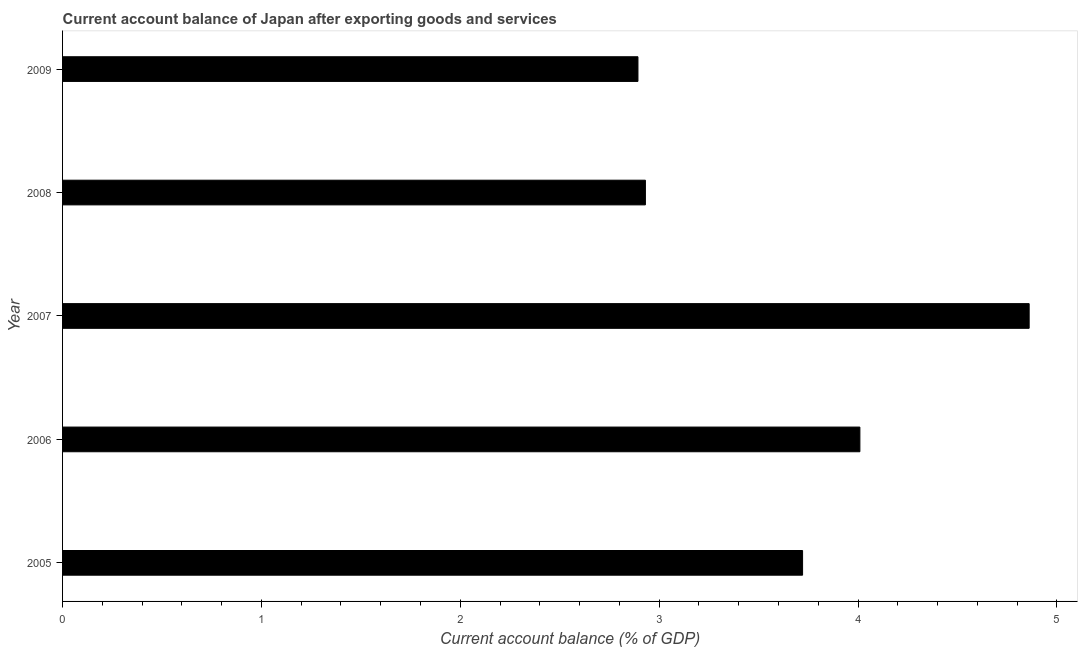Does the graph contain any zero values?
Your answer should be compact. No. What is the title of the graph?
Ensure brevity in your answer.  Current account balance of Japan after exporting goods and services. What is the label or title of the X-axis?
Your answer should be very brief. Current account balance (% of GDP). What is the current account balance in 2009?
Offer a terse response. 2.89. Across all years, what is the maximum current account balance?
Your answer should be compact. 4.86. Across all years, what is the minimum current account balance?
Make the answer very short. 2.89. In which year was the current account balance minimum?
Your response must be concise. 2009. What is the sum of the current account balance?
Give a very brief answer. 18.41. What is the difference between the current account balance in 2006 and 2008?
Offer a terse response. 1.08. What is the average current account balance per year?
Provide a short and direct response. 3.68. What is the median current account balance?
Your response must be concise. 3.72. Do a majority of the years between 2008 and 2007 (inclusive) have current account balance greater than 2.2 %?
Provide a succinct answer. No. What is the ratio of the current account balance in 2006 to that in 2009?
Your answer should be compact. 1.39. Is the current account balance in 2005 less than that in 2006?
Provide a short and direct response. Yes. Is the difference between the current account balance in 2005 and 2006 greater than the difference between any two years?
Your answer should be very brief. No. What is the difference between the highest and the second highest current account balance?
Provide a succinct answer. 0.85. Is the sum of the current account balance in 2007 and 2008 greater than the maximum current account balance across all years?
Keep it short and to the point. Yes. What is the difference between the highest and the lowest current account balance?
Provide a short and direct response. 1.97. In how many years, is the current account balance greater than the average current account balance taken over all years?
Your response must be concise. 3. How many bars are there?
Your answer should be compact. 5. What is the difference between two consecutive major ticks on the X-axis?
Provide a succinct answer. 1. What is the Current account balance (% of GDP) of 2005?
Provide a succinct answer. 3.72. What is the Current account balance (% of GDP) of 2006?
Provide a succinct answer. 4.01. What is the Current account balance (% of GDP) of 2007?
Your answer should be very brief. 4.86. What is the Current account balance (% of GDP) in 2008?
Your answer should be compact. 2.93. What is the Current account balance (% of GDP) of 2009?
Offer a very short reply. 2.89. What is the difference between the Current account balance (% of GDP) in 2005 and 2006?
Provide a short and direct response. -0.29. What is the difference between the Current account balance (% of GDP) in 2005 and 2007?
Your response must be concise. -1.14. What is the difference between the Current account balance (% of GDP) in 2005 and 2008?
Ensure brevity in your answer.  0.79. What is the difference between the Current account balance (% of GDP) in 2005 and 2009?
Provide a succinct answer. 0.83. What is the difference between the Current account balance (% of GDP) in 2006 and 2007?
Your response must be concise. -0.85. What is the difference between the Current account balance (% of GDP) in 2006 and 2008?
Keep it short and to the point. 1.08. What is the difference between the Current account balance (% of GDP) in 2006 and 2009?
Make the answer very short. 1.12. What is the difference between the Current account balance (% of GDP) in 2007 and 2008?
Your answer should be very brief. 1.93. What is the difference between the Current account balance (% of GDP) in 2007 and 2009?
Your response must be concise. 1.97. What is the difference between the Current account balance (% of GDP) in 2008 and 2009?
Provide a short and direct response. 0.04. What is the ratio of the Current account balance (% of GDP) in 2005 to that in 2006?
Your response must be concise. 0.93. What is the ratio of the Current account balance (% of GDP) in 2005 to that in 2007?
Provide a succinct answer. 0.77. What is the ratio of the Current account balance (% of GDP) in 2005 to that in 2008?
Provide a succinct answer. 1.27. What is the ratio of the Current account balance (% of GDP) in 2005 to that in 2009?
Offer a terse response. 1.29. What is the ratio of the Current account balance (% of GDP) in 2006 to that in 2007?
Provide a short and direct response. 0.82. What is the ratio of the Current account balance (% of GDP) in 2006 to that in 2008?
Your answer should be compact. 1.37. What is the ratio of the Current account balance (% of GDP) in 2006 to that in 2009?
Offer a terse response. 1.39. What is the ratio of the Current account balance (% of GDP) in 2007 to that in 2008?
Give a very brief answer. 1.66. What is the ratio of the Current account balance (% of GDP) in 2007 to that in 2009?
Your answer should be compact. 1.68. What is the ratio of the Current account balance (% of GDP) in 2008 to that in 2009?
Your response must be concise. 1.01. 